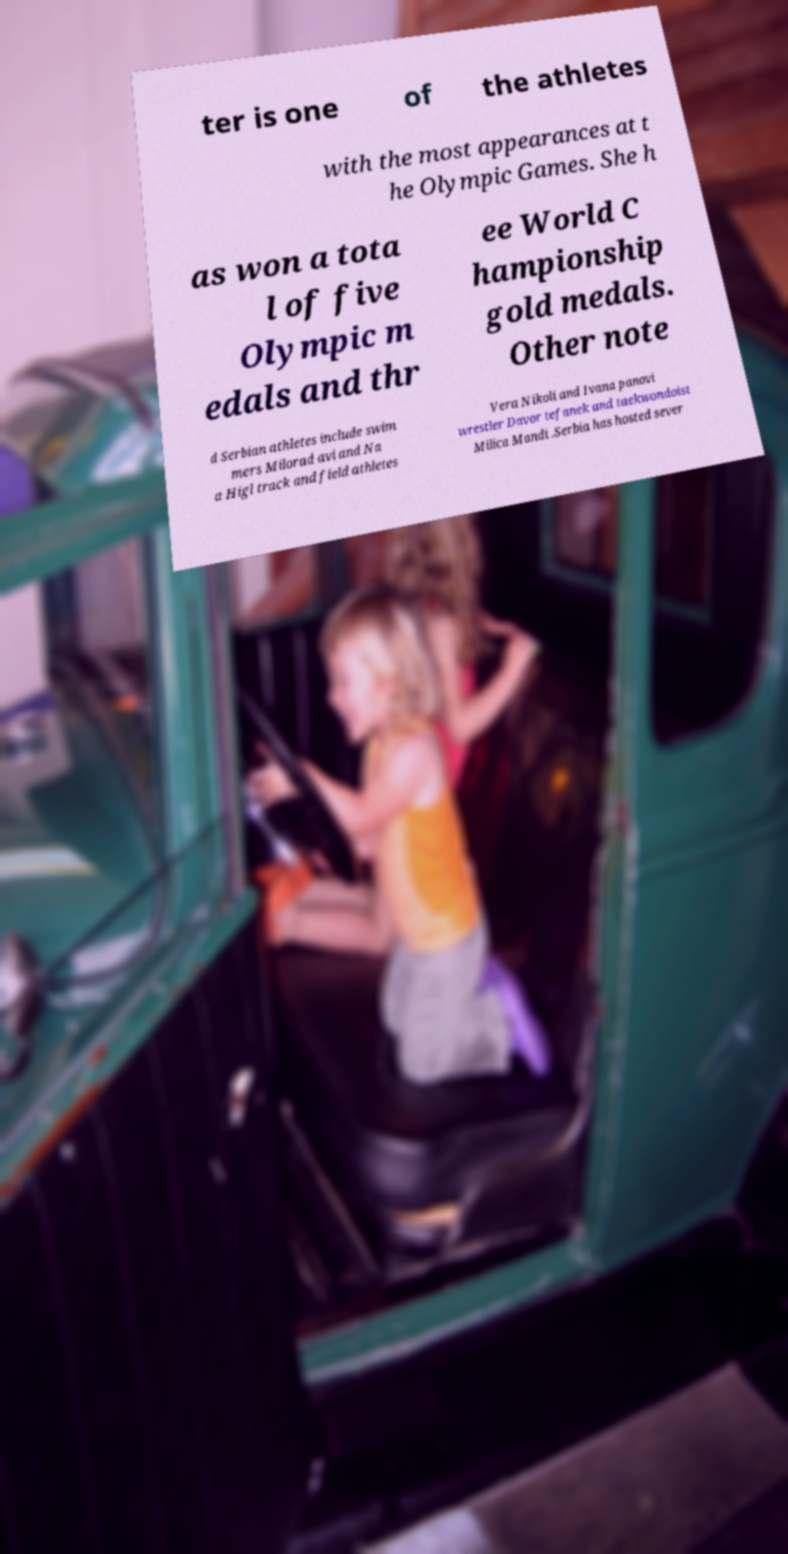For documentation purposes, I need the text within this image transcribed. Could you provide that? ter is one of the athletes with the most appearances at t he Olympic Games. She h as won a tota l of five Olympic m edals and thr ee World C hampionship gold medals. Other note d Serbian athletes include swim mers Milorad avi and Na a Higl track and field athletes Vera Nikoli and Ivana panovi wrestler Davor tefanek and taekwondoist Milica Mandi .Serbia has hosted sever 